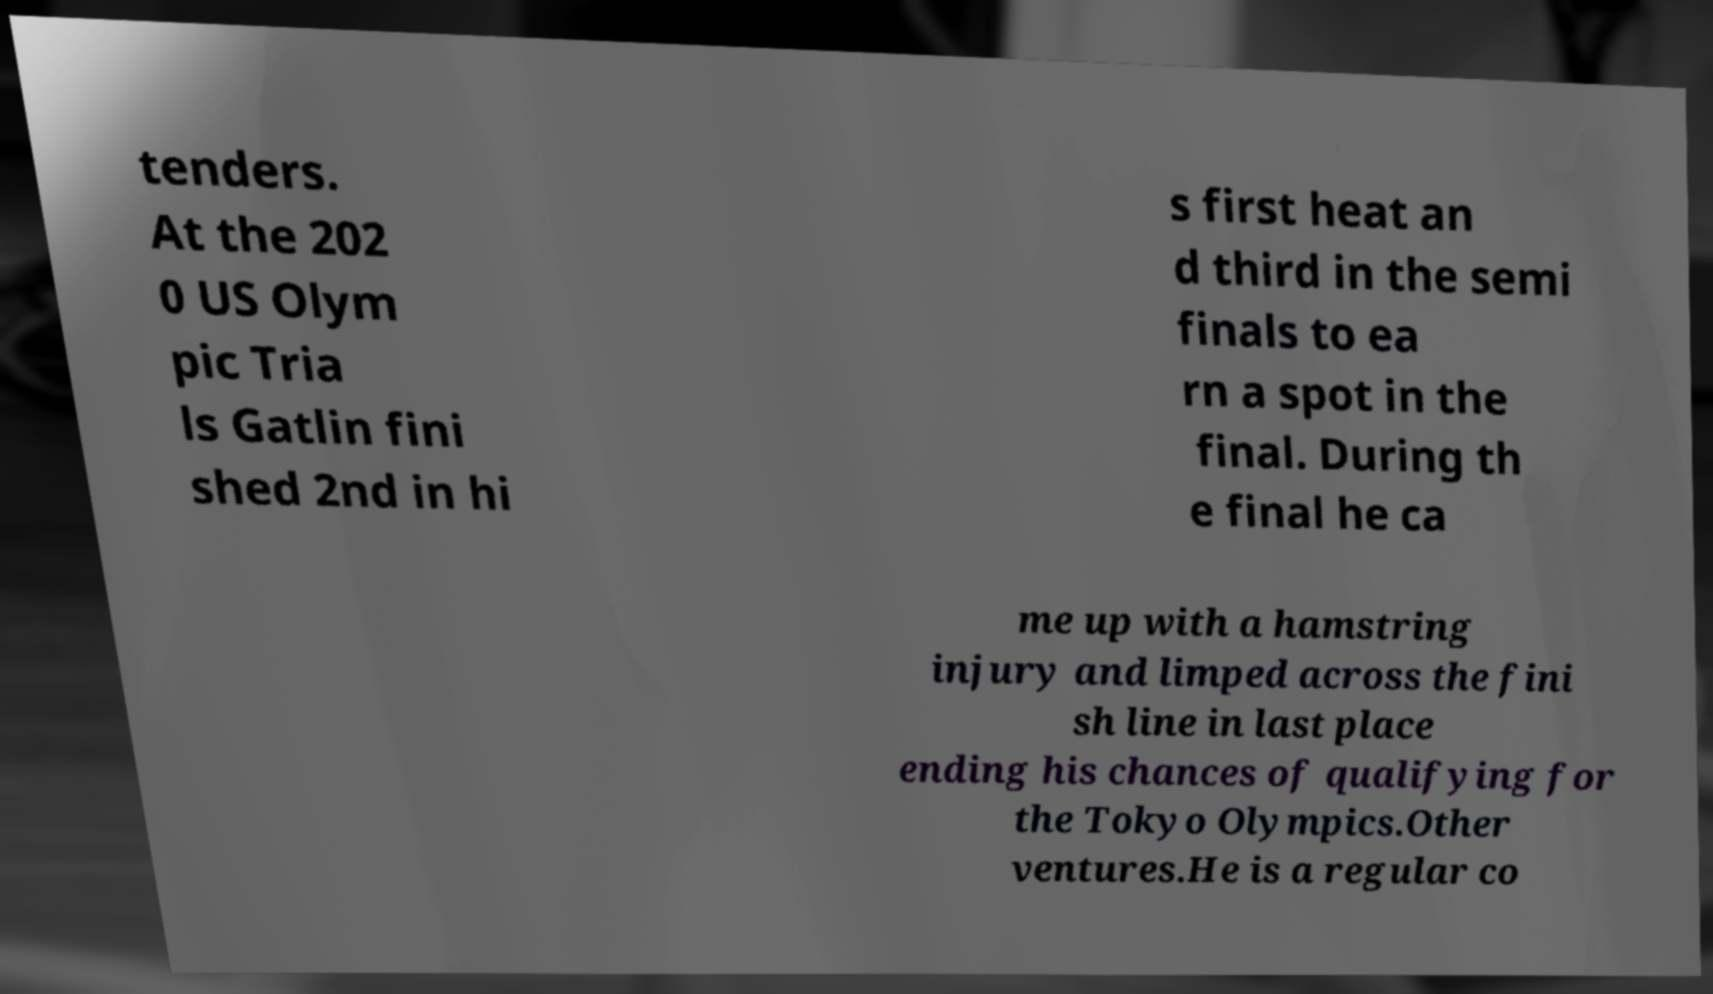What messages or text are displayed in this image? I need them in a readable, typed format. tenders. At the 202 0 US Olym pic Tria ls Gatlin fini shed 2nd in hi s first heat an d third in the semi finals to ea rn a spot in the final. During th e final he ca me up with a hamstring injury and limped across the fini sh line in last place ending his chances of qualifying for the Tokyo Olympics.Other ventures.He is a regular co 